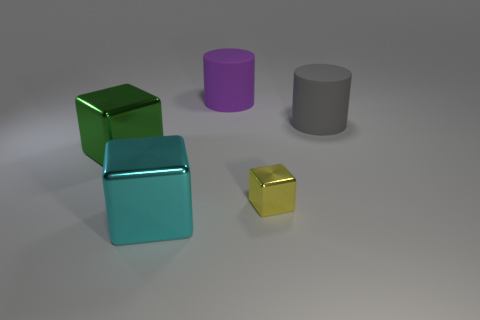Is there anything else that is the same size as the yellow block?
Provide a succinct answer. No. How big is the metal thing right of the large metal cube that is right of the large green cube?
Offer a terse response. Small. There is another matte thing that is the same shape as the purple matte thing; what color is it?
Your answer should be very brief. Gray. What size is the yellow shiny thing?
Give a very brief answer. Small. How many balls are either big gray rubber objects or large purple objects?
Make the answer very short. 0. There is a cyan object that is the same shape as the tiny yellow shiny object; what size is it?
Offer a very short reply. Large. What number of large cyan cubes are there?
Provide a short and direct response. 1. Does the big green metallic object have the same shape as the tiny thing in front of the gray rubber object?
Your answer should be compact. Yes. What size is the purple rubber object behind the green shiny block?
Make the answer very short. Large. What material is the large cyan block?
Offer a terse response. Metal. 